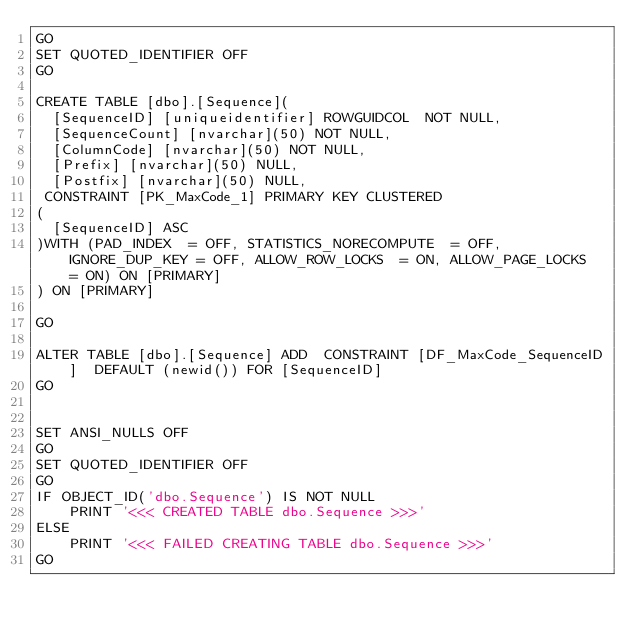Convert code to text. <code><loc_0><loc_0><loc_500><loc_500><_SQL_>GO
SET QUOTED_IDENTIFIER OFF
GO

CREATE TABLE [dbo].[Sequence](
	[SequenceID] [uniqueidentifier] ROWGUIDCOL  NOT NULL,
	[SequenceCount] [nvarchar](50) NOT NULL,
	[ColumnCode] [nvarchar](50) NOT NULL,
	[Prefix] [nvarchar](50) NULL,
	[Postfix] [nvarchar](50) NULL,
 CONSTRAINT [PK_MaxCode_1] PRIMARY KEY CLUSTERED 
(
	[SequenceID] ASC
)WITH (PAD_INDEX  = OFF, STATISTICS_NORECOMPUTE  = OFF, IGNORE_DUP_KEY = OFF, ALLOW_ROW_LOCKS  = ON, ALLOW_PAGE_LOCKS  = ON) ON [PRIMARY]
) ON [PRIMARY]

GO

ALTER TABLE [dbo].[Sequence] ADD  CONSTRAINT [DF_MaxCode_SequenceID]  DEFAULT (newid()) FOR [SequenceID]
GO


SET ANSI_NULLS OFF
GO
SET QUOTED_IDENTIFIER OFF
GO
IF OBJECT_ID('dbo.Sequence') IS NOT NULL
    PRINT '<<< CREATED TABLE dbo.Sequence >>>'
ELSE
    PRINT '<<< FAILED CREATING TABLE dbo.Sequence >>>'
GO</code> 